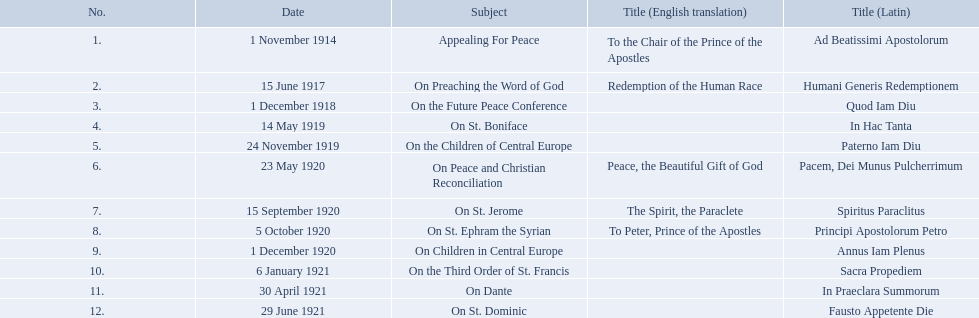What are all the subjects? Appealing For Peace, On Preaching the Word of God, On the Future Peace Conference, On St. Boniface, On the Children of Central Europe, On Peace and Christian Reconciliation, On St. Jerome, On St. Ephram the Syrian, On Children in Central Europe, On the Third Order of St. Francis, On Dante, On St. Dominic. Which occurred in 1920? On Peace and Christian Reconciliation, On St. Jerome, On St. Ephram the Syrian, On Children in Central Europe. Which occurred in may of that year? On Peace and Christian Reconciliation. 